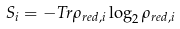Convert formula to latex. <formula><loc_0><loc_0><loc_500><loc_500>S _ { i } = - T r \rho _ { r e d , i } \log _ { 2 } \rho _ { r e d , i }</formula> 